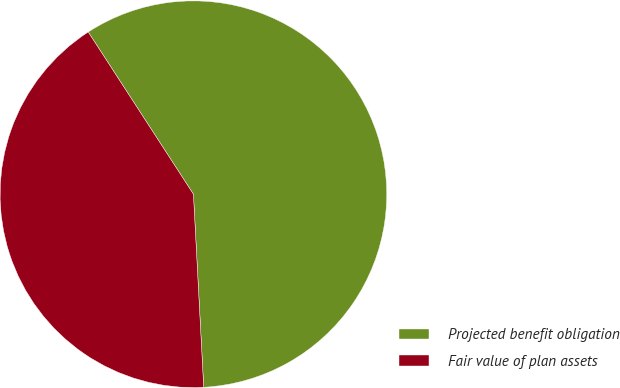Convert chart to OTSL. <chart><loc_0><loc_0><loc_500><loc_500><pie_chart><fcel>Projected benefit obligation<fcel>Fair value of plan assets<nl><fcel>58.31%<fcel>41.69%<nl></chart> 